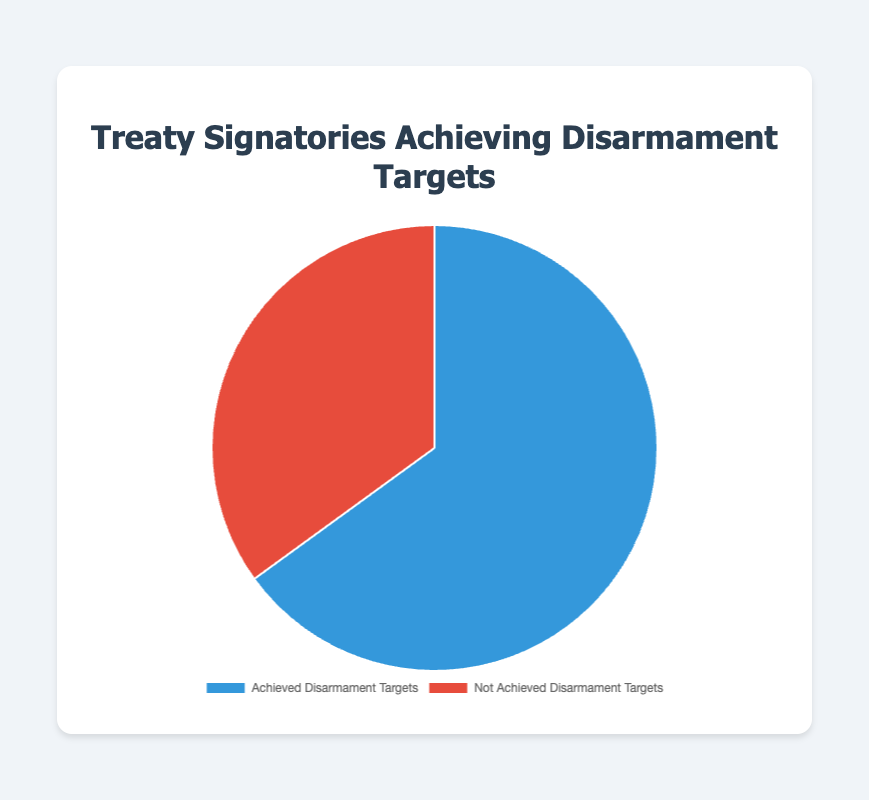What percentage of treaty signatories have achieved disarmament targets? The pie chart shows two categories: "Achieved Disarmament Targets" and "Not Achieved Disarmament Targets". The percentage for "Achieved Disarmament Targets" is explicitly stated as 65%.
Answer: 65% What is the difference in percentages between treaty signatories that achieved and did not achieve disarmament targets? The percentage for "Achieved Disarmament Targets" is 65%, and the percentage for "Not Achieved Disarmament Targets" is 35%. The difference can be calculated by subtracting 35 from 65.
Answer: 30% Which category occupies the larger portion of the pie chart? By looking at the visual representation, the blue section labeled "Achieved Disarmament Targets" is larger than the red section labeled "Not Achieved Disarmament Targets".
Answer: Achieved Disarmament Targets What is the combined percentage of treaty signatories associated with the New START Treaty? Both the United States and Russia are associated with the New START Treaty and are included in the "Not Achieved Disarmament Targets" category, which collectively accounts for 35% of the total.
Answer: 35% How many countries are listed in the details for signatories that achieved disarmament targets? The details list three countries under the "Achieved Disarmament Targets" category: Norway, New Zealand, and South Africa.
Answer: 3 What is the ratio of countries that achieved disarmament targets to those that did not? There are 3 countries listed under "Achieved Disarmament Targets" and 3 countries listed under "Not Achieved Disarmament Targets". The ratio is 3:3, which simplifies to 1:1.
Answer: 1:1 Considering visual attributes, which color represents the signatories that did not achieve disarmament targets? The section representing "Not Achieved Disarmament Targets" is colored red in the pie chart.
Answer: Red What would be the percentage if one more country had achieved disarmament targets? Initially, 65% of treaty signatories achieved disarmament targets. Adding one more country would change the percentages but requires additional data for precise recalculation. However, the percentage would increase.
Answer: Increases If the percentage of treaty signatories achieving targets increased by 10%, what would the new percentage be? Adding 10% to the current 65% for "Achieved Disarmament Targets" results in a new percentage of 75%.
Answer: 75% Which treaty in the "Achieved Disarmament Targets" category was signed the earliest? The details show South Africa signing the African Nuclear-Weapon-Free Zone Treaty in 1996, which is the earliest date listed.
Answer: African Nuclear-Weapon-Free Zone Treaty 